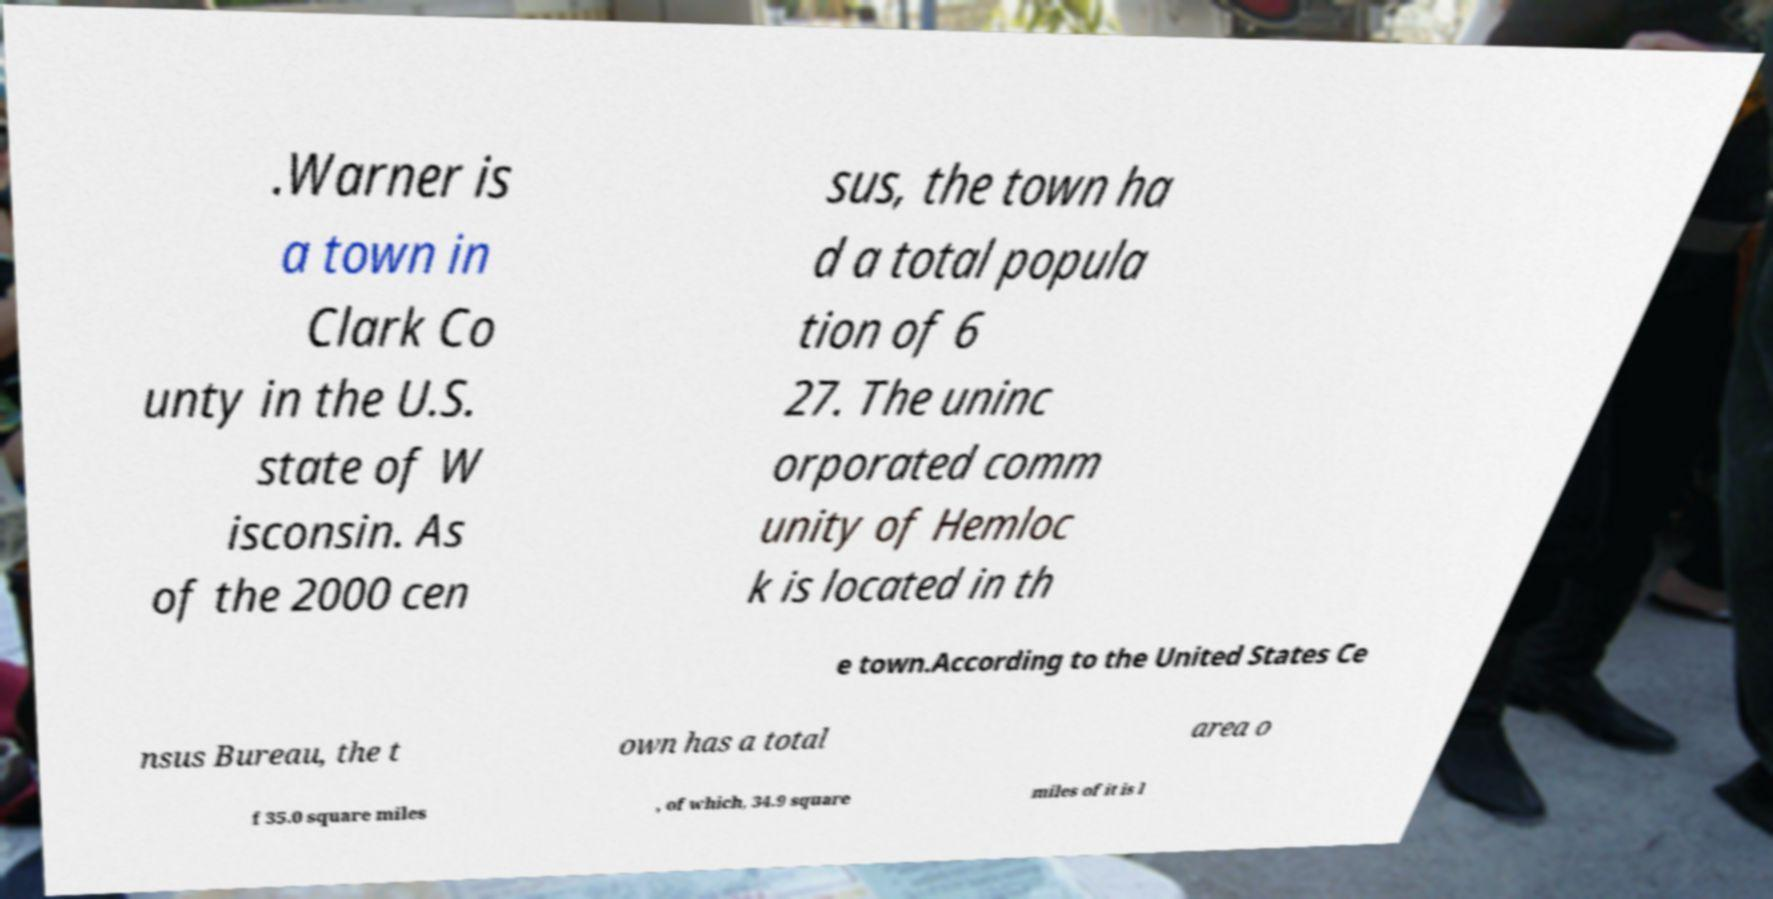There's text embedded in this image that I need extracted. Can you transcribe it verbatim? .Warner is a town in Clark Co unty in the U.S. state of W isconsin. As of the 2000 cen sus, the town ha d a total popula tion of 6 27. The uninc orporated comm unity of Hemloc k is located in th e town.According to the United States Ce nsus Bureau, the t own has a total area o f 35.0 square miles , of which, 34.9 square miles of it is l 